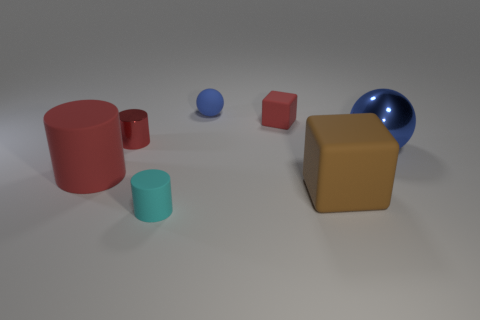Subtract all cyan rubber cylinders. How many cylinders are left? 2 Subtract all red cylinders. How many were subtracted if there are1red cylinders left? 1 Subtract 1 cubes. How many cubes are left? 1 Subtract all yellow cylinders. Subtract all blue blocks. How many cylinders are left? 3 Subtract all brown cylinders. How many red cubes are left? 1 Subtract all large purple shiny cylinders. Subtract all big brown objects. How many objects are left? 6 Add 1 small blue matte things. How many small blue matte things are left? 2 Add 4 big things. How many big things exist? 7 Add 2 large things. How many objects exist? 9 Subtract all cyan cylinders. How many cylinders are left? 2 